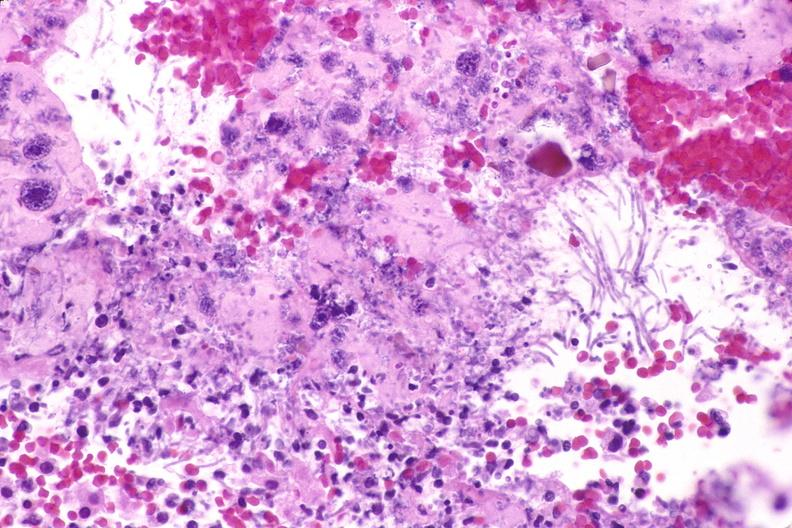where is this from?
Answer the question using a single word or phrase. Gastrointestinal system 